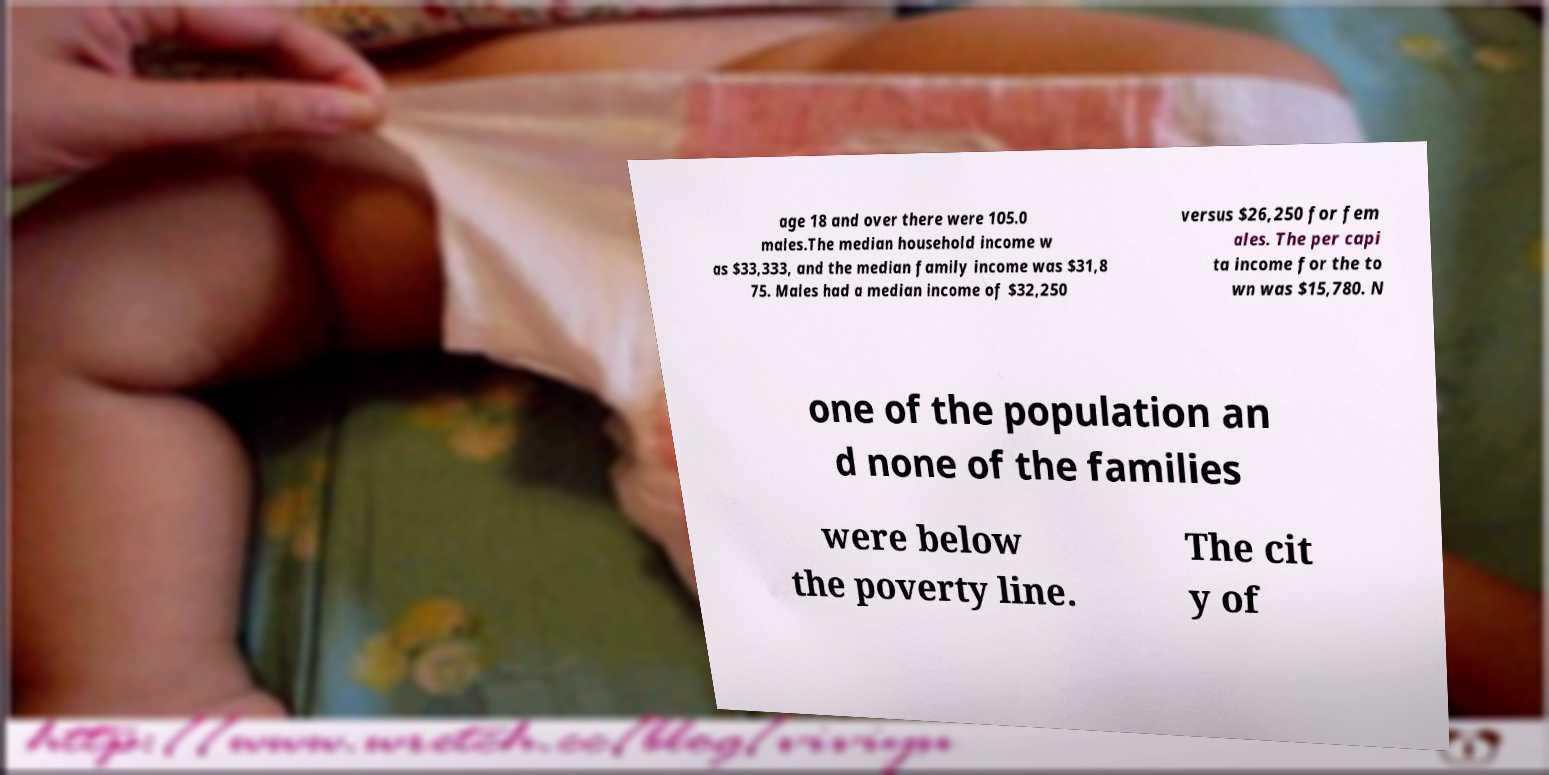Can you accurately transcribe the text from the provided image for me? age 18 and over there were 105.0 males.The median household income w as $33,333, and the median family income was $31,8 75. Males had a median income of $32,250 versus $26,250 for fem ales. The per capi ta income for the to wn was $15,780. N one of the population an d none of the families were below the poverty line. The cit y of 